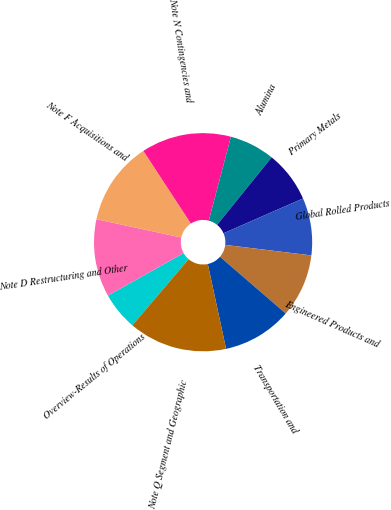<chart> <loc_0><loc_0><loc_500><loc_500><pie_chart><fcel>Overview-Results of Operations<fcel>Note D Restructuring and Other<fcel>Note F Acquisitions and<fcel>Note N Contingencies and<fcel>Alumina<fcel>Primary Metals<fcel>Global Rolled Products<fcel>Engineered Products and<fcel>Transportation and<fcel>Note Q Segment and Geographic<nl><fcel>5.65%<fcel>11.51%<fcel>12.4%<fcel>13.32%<fcel>6.71%<fcel>7.61%<fcel>8.5%<fcel>9.4%<fcel>10.29%<fcel>14.6%<nl></chart> 